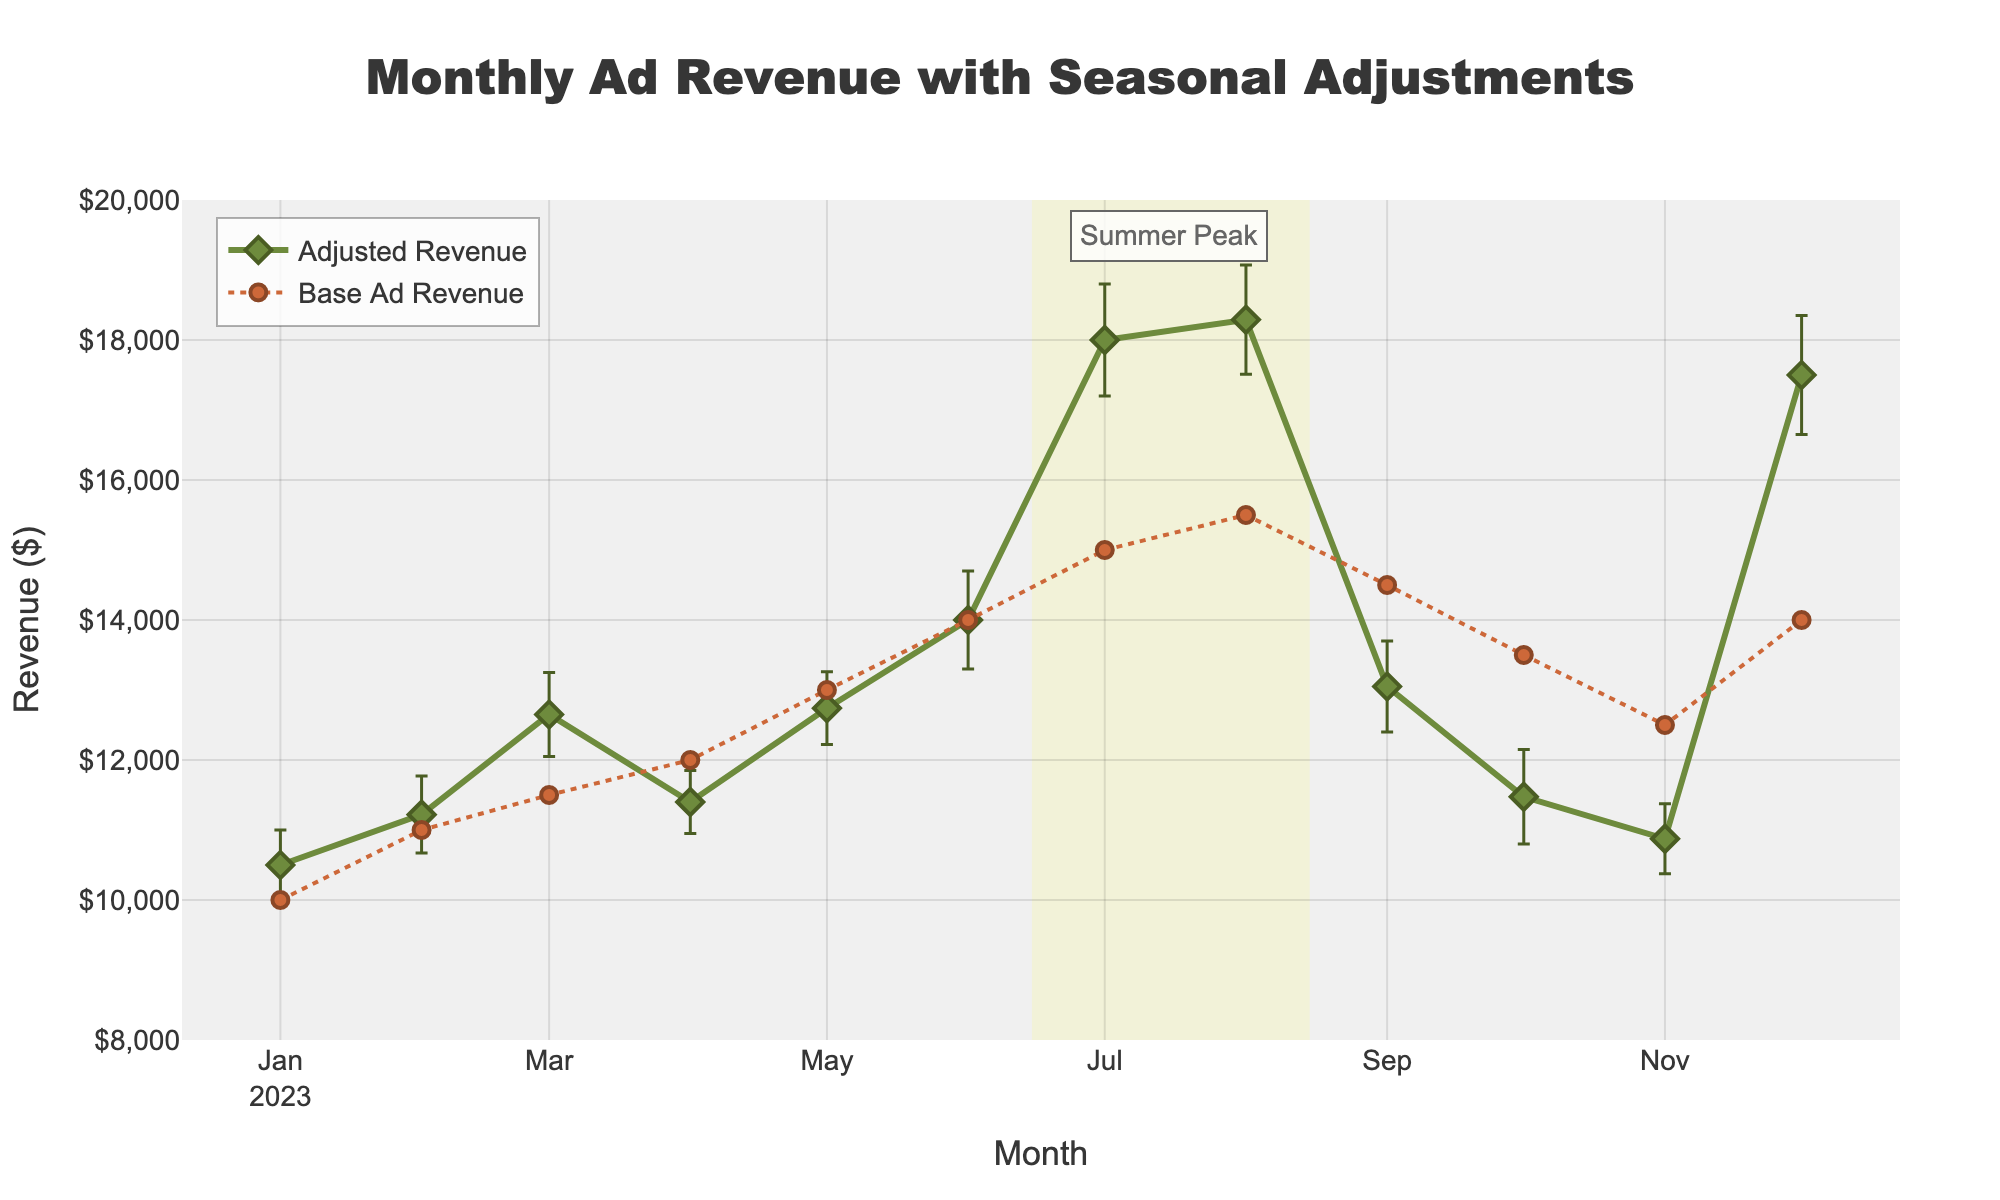What is the title of the figure? The title of the figure is prominently displayed at the top and reads "Monthly Ad Revenue with Seasonal Adjustments".
Answer: Monthly Ad Revenue with Seasonal Adjustments What is the highest value of Adjusted Revenue, and in which month does it occur? By observing the Adjusted Revenue trace, the highest value is approximately $18290 and it occurs in August.
Answer: $18290 in August What is the range of the y-axis? The y-axis range is from $8000 to $20000, as specified in the plot's layout.
Answer: $8000 to $20000 Which months are highlighted as the "Summer Peak"? A highlighted rectangle spans from mid-June to mid-August, labeled as "Summer Peak" around July.
Answer: Mid-June to mid-August What is the Base Ad Revenue for April? Looking at the Base Ad Revenue trace, April's value is 12000, indicated by the dot near the month of April.
Answer: 12000 What is the difference between the Adjusted Revenue and the Base Ad Revenue in July? Adjusted Revenue in July is 18000, and Base Ad Revenue is 15000. The difference is 18000 - 15000 = 3000.
Answer: 3000 How do the error bars visually affect the interpretation of Adjusted Revenue values? Error bars provide an uncertainty range around each data point, indicating that the actual Adjusted Revenue could be within a certain range above or below the plotted point.
Answer: Provides uncertainty range Which month has the largest error bar for Adjusted Revenue? Observing the error bars, December has the largest error bar for Adjusted Revenue, indicating the most uncertainty or variability.
Answer: December What trend can be observed in Adjusted Revenue over the year? Adjusted Revenue generally increases until peaks in summer months, declines in fall, and has another peak in December, showing a seasonal pattern.
Answer: Seasonal pattern with summer and December peaks How does the Base Ad Revenue compare with Adjusted Revenue in December? In December, Base Ad Revenue is 14000 and Adjusted Revenue is 17500. Adjusted Revenue is significantly higher than Base Ad Revenue, indicating a seasonal uplift.
Answer: Adjusted Revenue is 3500 higher 